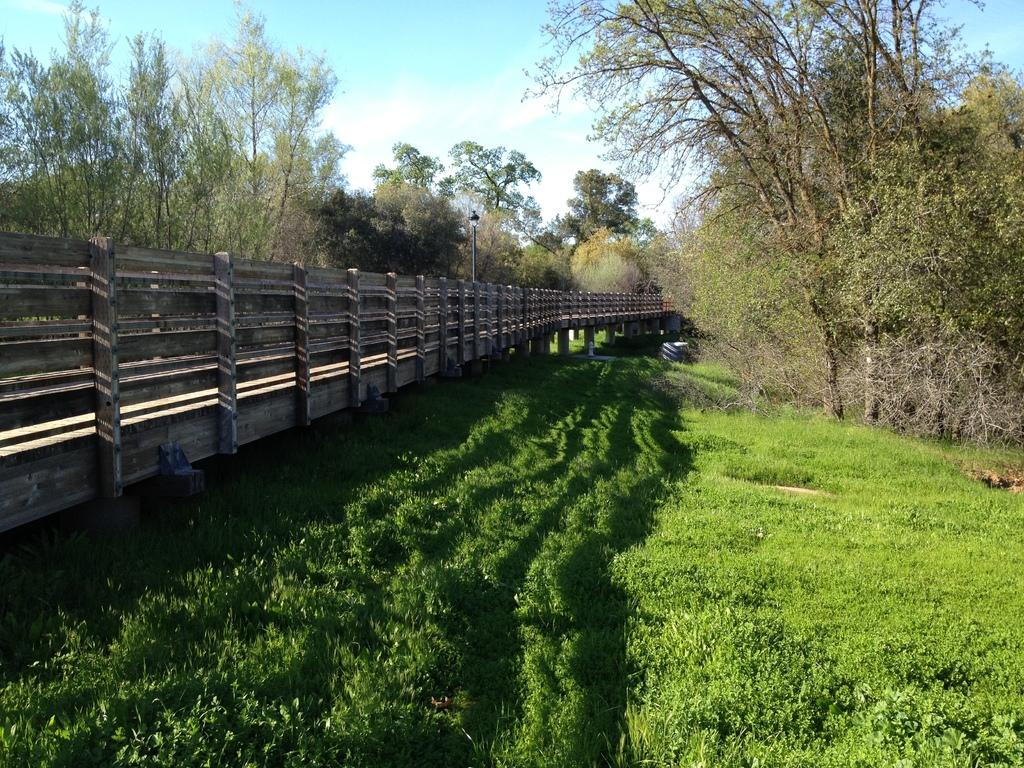What structure is present in the image? There is a bridge in the image. What else can be seen in the image besides the bridge? There is a pole in the image. What is visible in the background of the image? There are trees in the background of the image. What is the surface on which the bridge and pole are standing? The ground is visible in the image. What type of vegetation covers the ground in the image? The ground is covered with grass. How many rings are hanging from the bridge in the image? There are no rings hanging from the bridge in the image. What type of curve can be seen in the image? The image does not depict a curve; it features a bridge and a pole. 